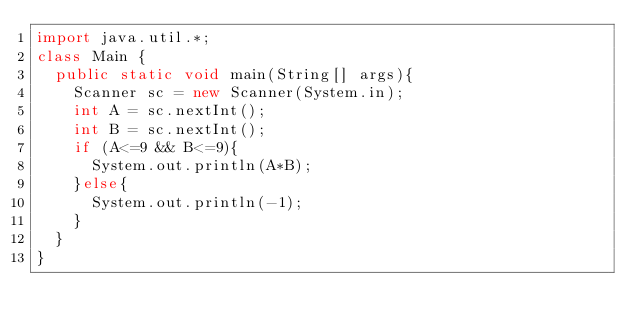<code> <loc_0><loc_0><loc_500><loc_500><_Java_>import java.util.*;
class Main {
  public static void main(String[] args){
    Scanner sc = new Scanner(System.in);
    int A = sc.nextInt();
    int B = sc.nextInt();
    if (A<=9 && B<=9){
      System.out.println(A*B);
    }else{
      System.out.println(-1);
    }
  }
}</code> 